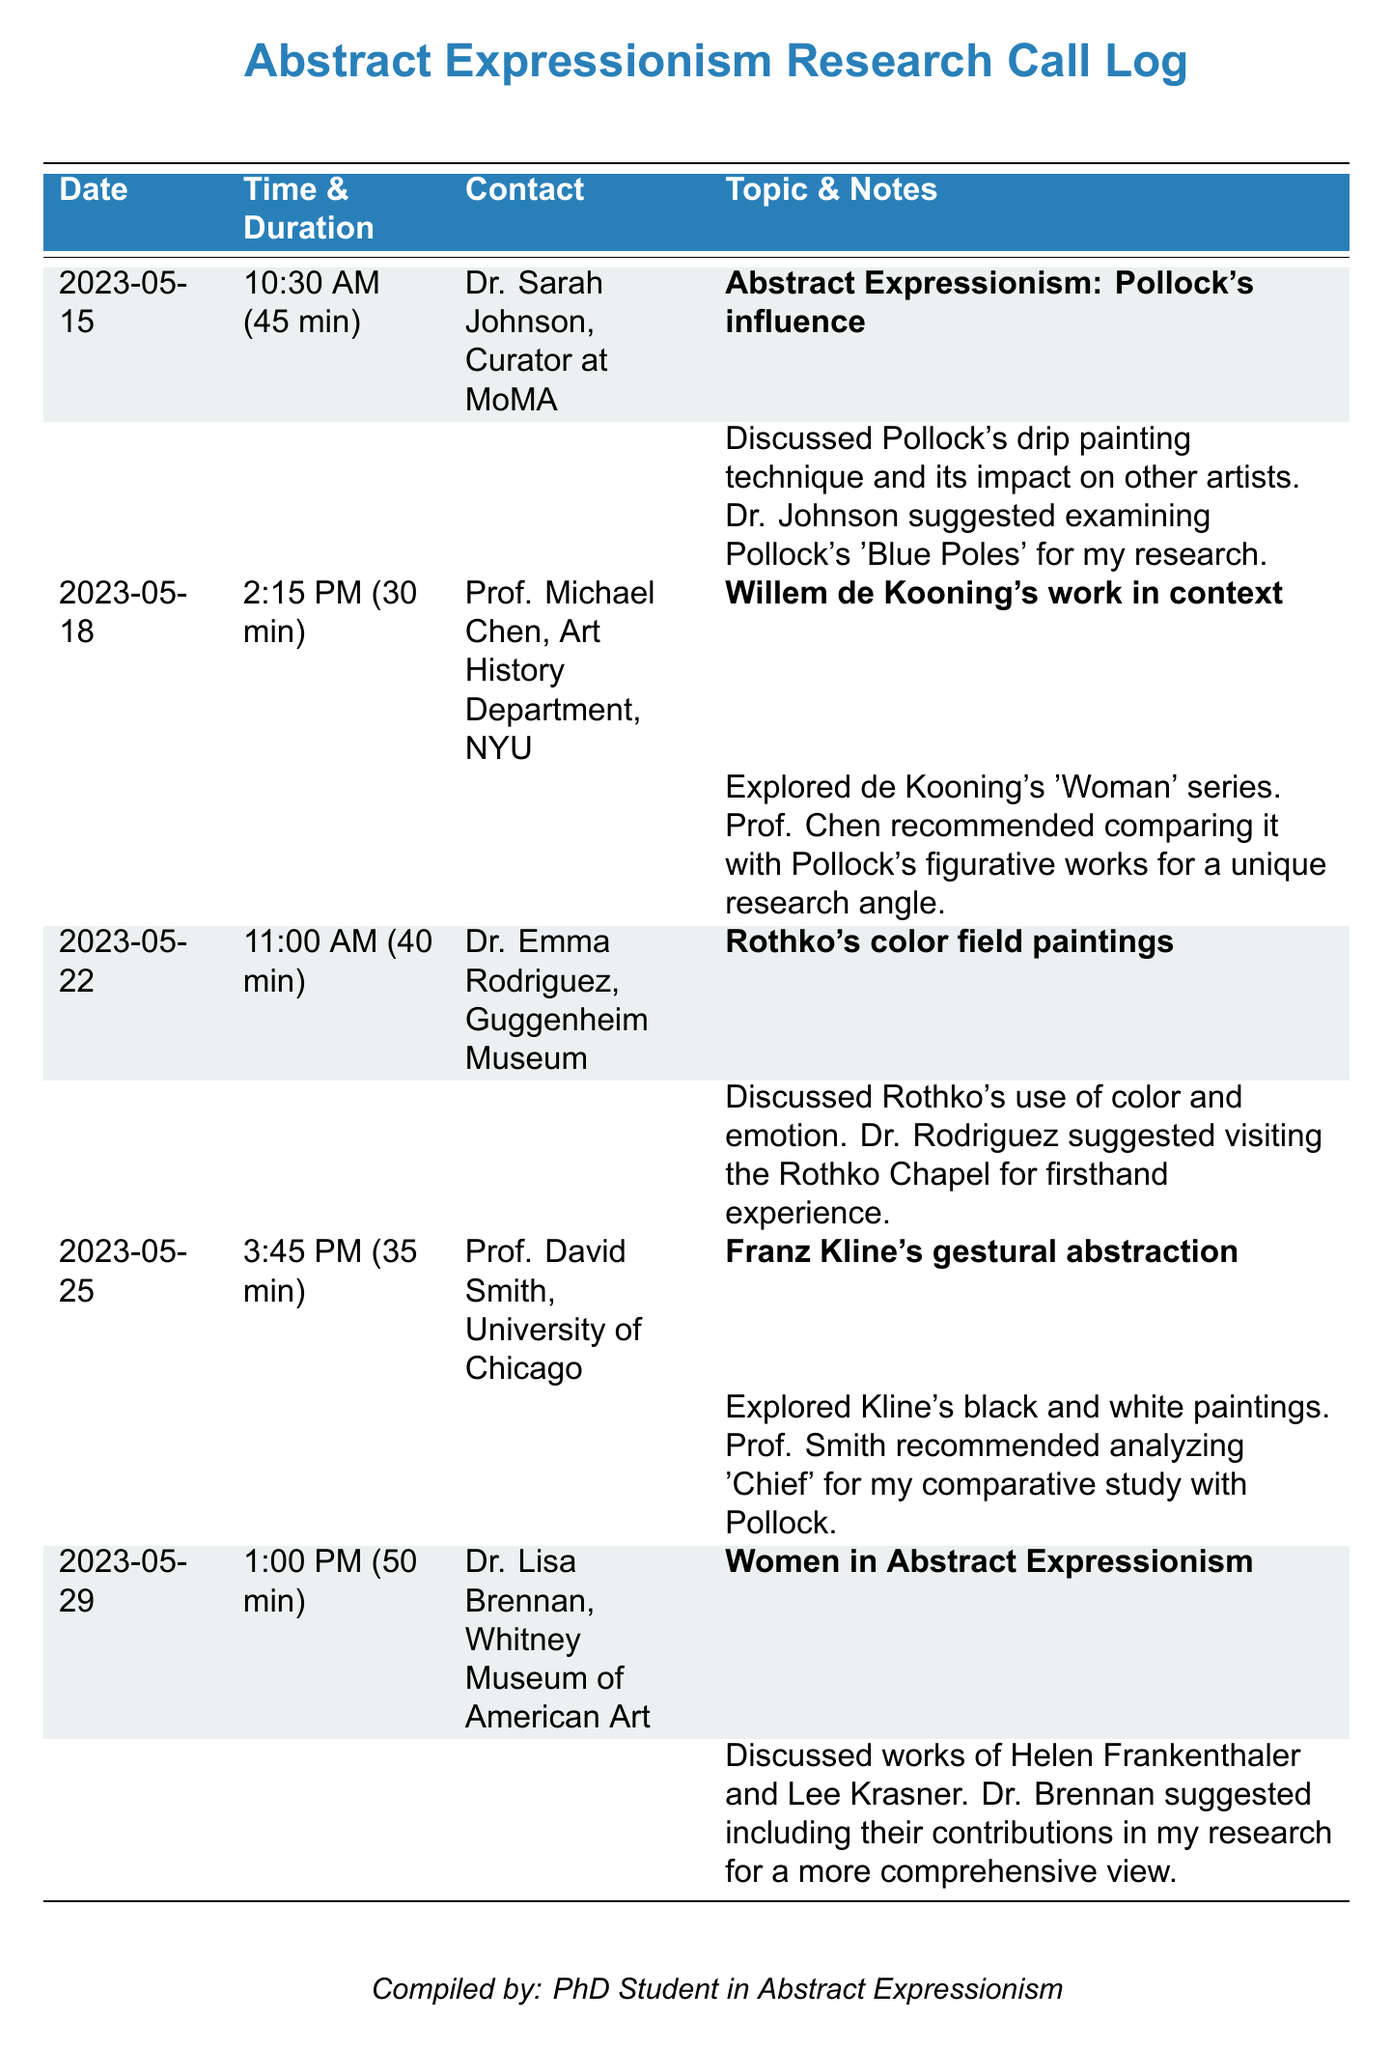What is the date of the first call? The date of the first call is the earliest date listed in the document, which is 2023-05-15.
Answer: 2023-05-15 Who did the student speak with about Rothko's color field paintings? The contact for Rothko's color field paintings discussion is Dr. Emma Rodriguez, as stated in the document.
Answer: Dr. Emma Rodriguez What was the duration of the conversation with Prof. David Smith? The duration is specified in the document as 35 minutes.
Answer: 35 min Which painting by Pollock was suggested for research? The document specifically mentions 'Blue Poles' as a recommended work to examine for research.
Answer: Blue Poles What is the primary topic discussed with Dr. Lisa Brennan? The primary topic discussed with Dr. Lisa Brennan was Women in Abstract Expressionism.
Answer: Women in Abstract Expressionism How many calls are recorded in the document? The total number of calls can be counted from the individual records, which totals five calls.
Answer: 5 Which artist's work is suggested for comparison with de Kooning's work? The document suggests comparing de Kooning's work with Pollock's figurative works.
Answer: Pollock What museum does Dr. Lisa Brennan work for? The document states that Dr. Lisa Brennan is associated with the Whitney Museum of American Art.
Answer: Whitney Museum of American Art 